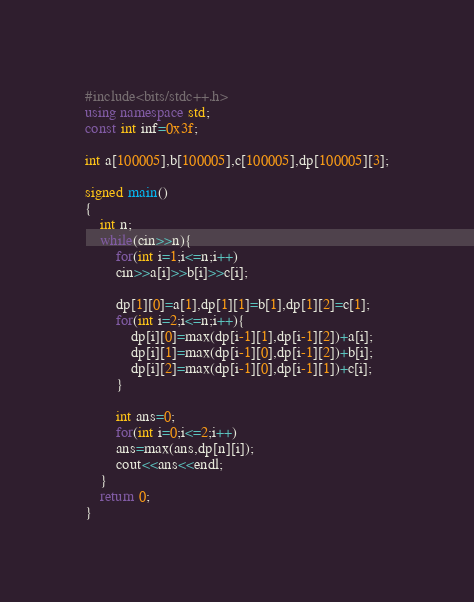Convert code to text. <code><loc_0><loc_0><loc_500><loc_500><_C++_>#include<bits/stdc++.h>
using namespace std;
const int inf=0x3f;

int a[100005],b[100005],c[100005],dp[100005][3];

signed main()
{
	int n;
	while(cin>>n){
		for(int i=1;i<=n;i++)
		cin>>a[i]>>b[i]>>c[i];
		
		dp[1][0]=a[1],dp[1][1]=b[1],dp[1][2]=c[1];
		for(int i=2;i<=n;i++){
			dp[i][0]=max(dp[i-1][1],dp[i-1][2])+a[i];
			dp[i][1]=max(dp[i-1][0],dp[i-1][2])+b[i];
			dp[i][2]=max(dp[i-1][0],dp[i-1][1])+c[i]; 
		}
		
		int ans=0;
		for(int i=0;i<=2;i++)
		ans=max(ans,dp[n][i]);
		cout<<ans<<endl;
	}
	return 0;
}</code> 